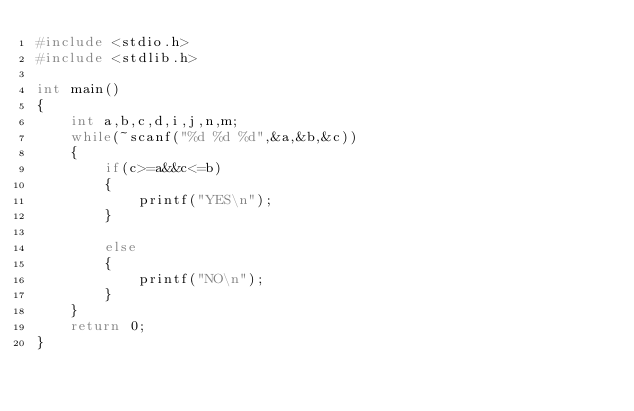<code> <loc_0><loc_0><loc_500><loc_500><_C_>#include <stdio.h>
#include <stdlib.h>

int main()
{
    int a,b,c,d,i,j,n,m;
    while(~scanf("%d %d %d",&a,&b,&c))
    {
        if(c>=a&&c<=b)
        {
            printf("YES\n");
        }

        else
        {
            printf("NO\n");
        }
    }
    return 0;
}
</code> 